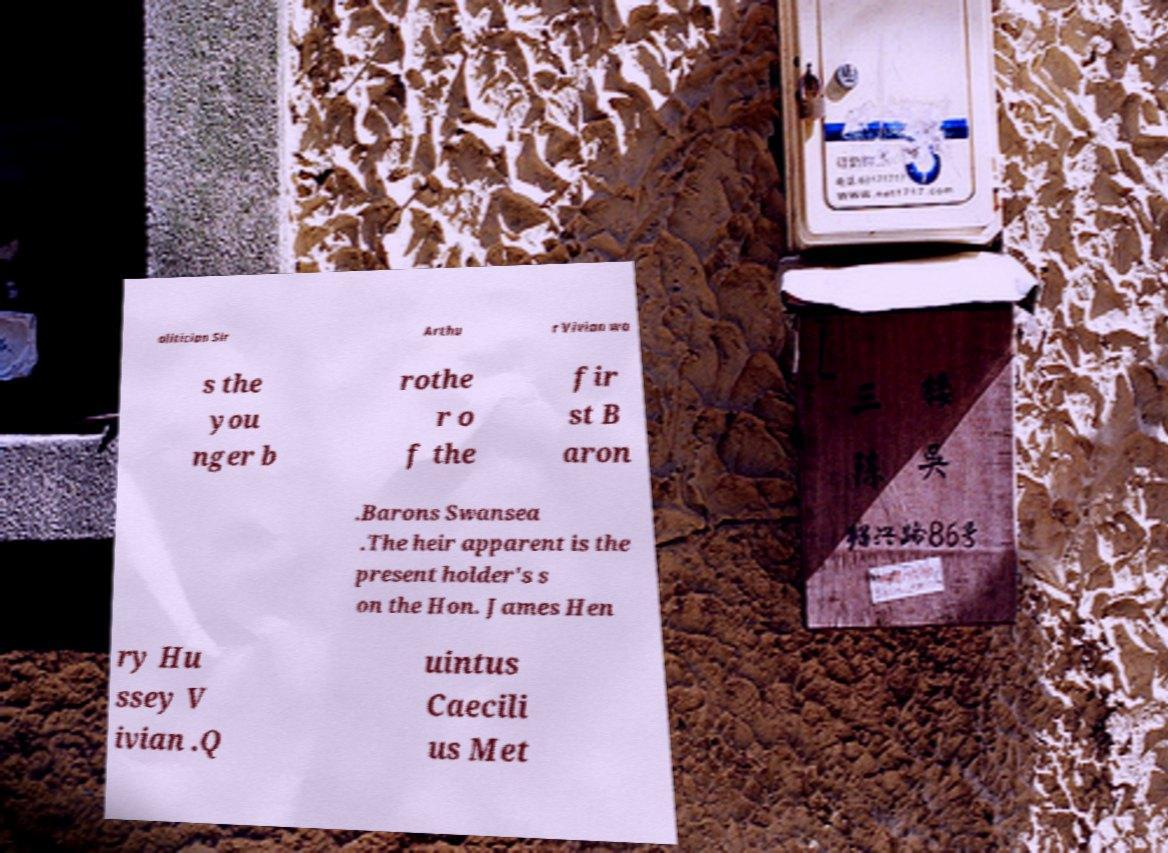For documentation purposes, I need the text within this image transcribed. Could you provide that? olitician Sir Arthu r Vivian wa s the you nger b rothe r o f the fir st B aron .Barons Swansea .The heir apparent is the present holder's s on the Hon. James Hen ry Hu ssey V ivian .Q uintus Caecili us Met 